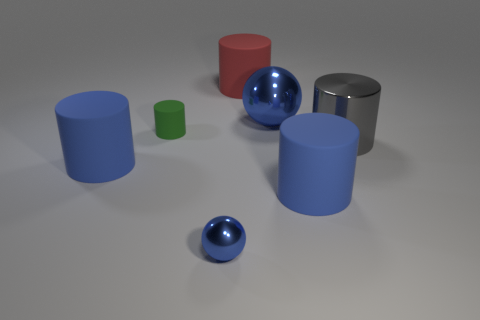How big is the blue rubber thing behind the big matte object to the right of the big blue shiny object?
Provide a succinct answer. Large. The rubber cylinder that is both to the right of the tiny blue metal thing and in front of the big gray shiny cylinder is what color?
Offer a very short reply. Blue. What number of other things are there of the same size as the red matte cylinder?
Give a very brief answer. 4. Is the size of the gray thing the same as the ball that is behind the metallic cylinder?
Give a very brief answer. Yes. The shiny cylinder that is the same size as the red thing is what color?
Ensure brevity in your answer.  Gray. How big is the green matte thing?
Offer a very short reply. Small. Are the cylinder on the left side of the tiny matte object and the red cylinder made of the same material?
Offer a terse response. Yes. Does the tiny blue metallic object have the same shape as the small matte thing?
Keep it short and to the point. No. The big rubber thing that is to the left of the blue metal thing that is in front of the blue thing that is on the right side of the large shiny ball is what shape?
Your response must be concise. Cylinder. Is the shape of the large shiny object to the left of the gray metal thing the same as the small thing in front of the large gray object?
Your answer should be compact. Yes. 